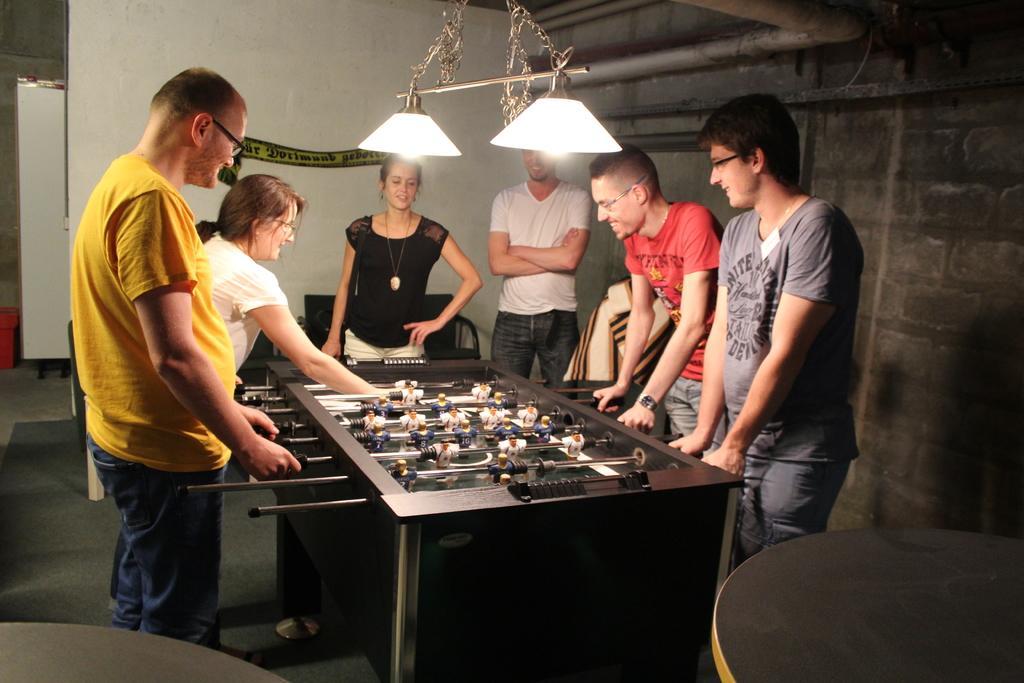Describe this image in one or two sentences. In this image we can see people standing near the Foosball table. In addition to this we can see electric lights and walls. 